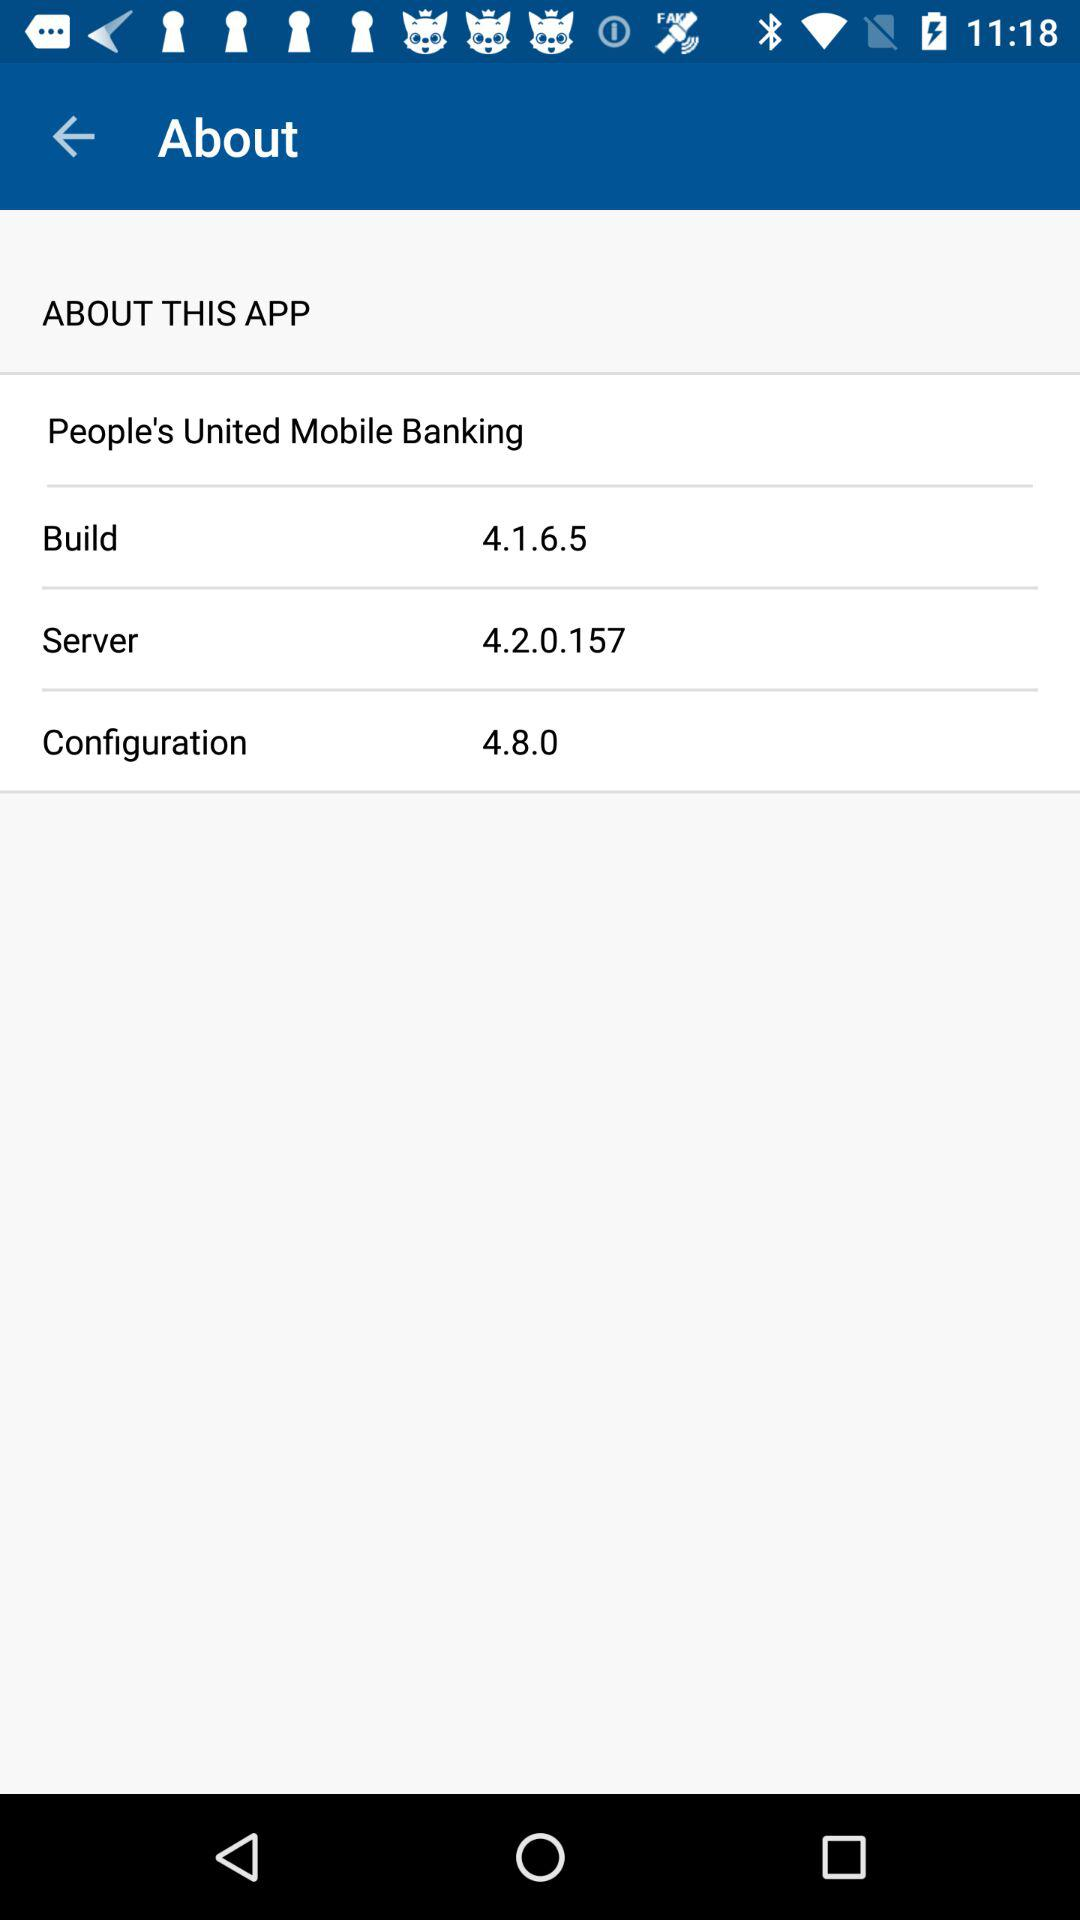Is "ABOUT THIS APP" checked or unchecked?
When the provided information is insufficient, respond with <no answer>. <no answer> 